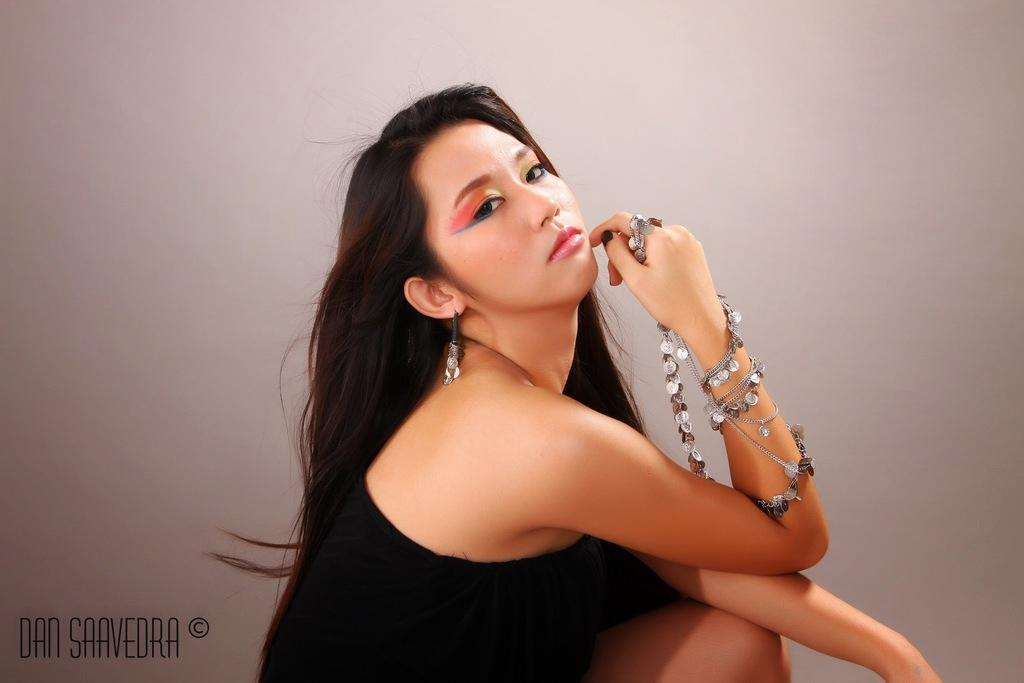Who is present in the image? There is a woman in the image. What else can be seen in the image besides the woman? There is text written on the image. Where is the text located in the image? The text is located in the bottom left corner of the image. What type of soap is being used by the woman in the image? There is no soap present in the image, as it only features a woman and text. What achievements has the woman in the image accomplished? There is no information about the woman's achievements in the image, as it only shows her presence and the text. 